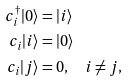<formula> <loc_0><loc_0><loc_500><loc_500>c _ { i } ^ { \dagger } | 0 \rangle & = | i \rangle \\ c _ { i } | i \rangle & = | 0 \rangle \\ c _ { i } | j \rangle & = 0 , \quad i \ne j ,</formula> 